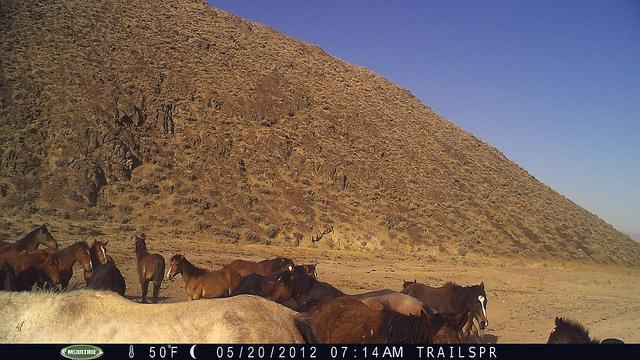How many horses can be seen?
Give a very brief answer. 4. 